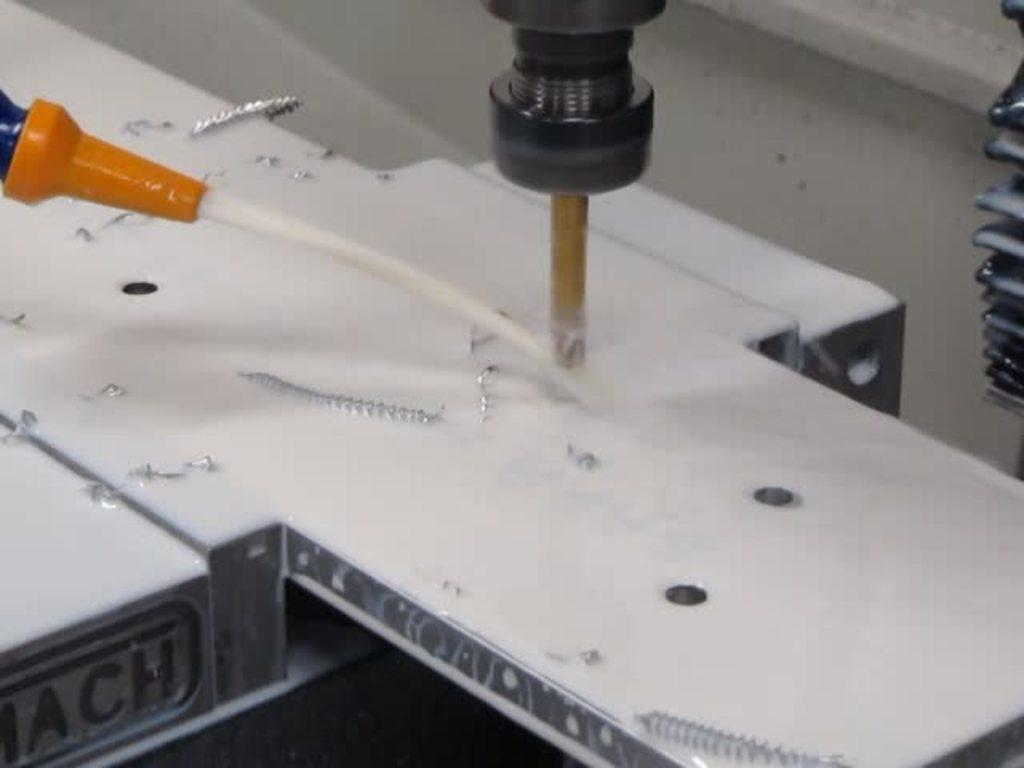What is the main object in the image? There is a plank in the image. What is placed on the plank? A drilling machine is present on the plank. What is the drilling machine doing? The drilling machine is drilling into the plank. What can be seen around the drilling machine? There are iron scraps visible around the drilling machine. What type of plane can be seen flying in the image? There is no plane visible in the image; it only features a plank with a drilling machine. How many units are present in the image? The concept of "units" is not mentioned or relevant in the image, as it only shows a plank, a drilling machine, and some iron scraps. 